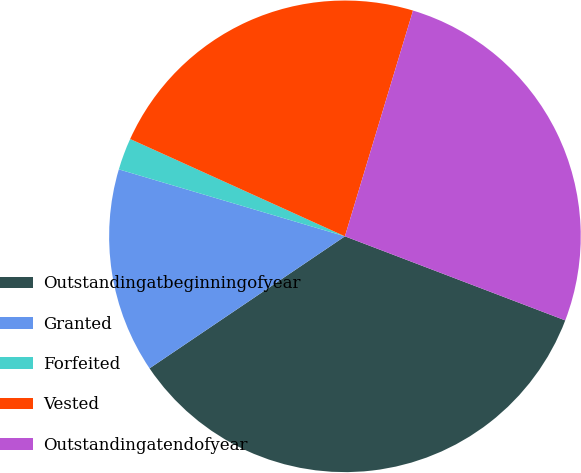Convert chart. <chart><loc_0><loc_0><loc_500><loc_500><pie_chart><fcel>Outstandingatbeginningofyear<fcel>Granted<fcel>Forfeited<fcel>Vested<fcel>Outstandingatendofyear<nl><fcel>34.74%<fcel>14.04%<fcel>2.19%<fcel>22.89%<fcel>26.14%<nl></chart> 